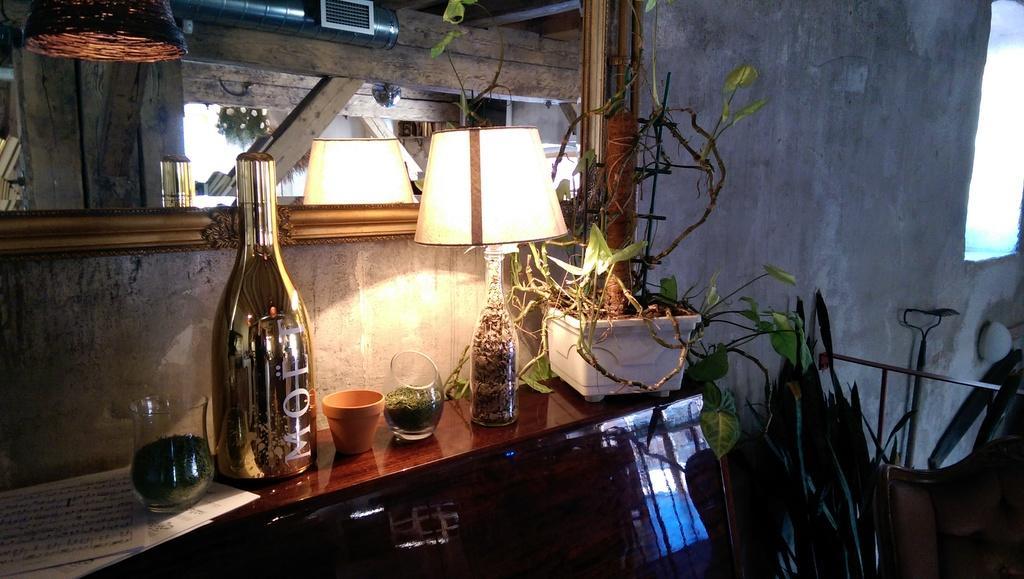Describe this image in one or two sentences. On this table there is a lantern lamp, pot, jar, bottle and plant. 